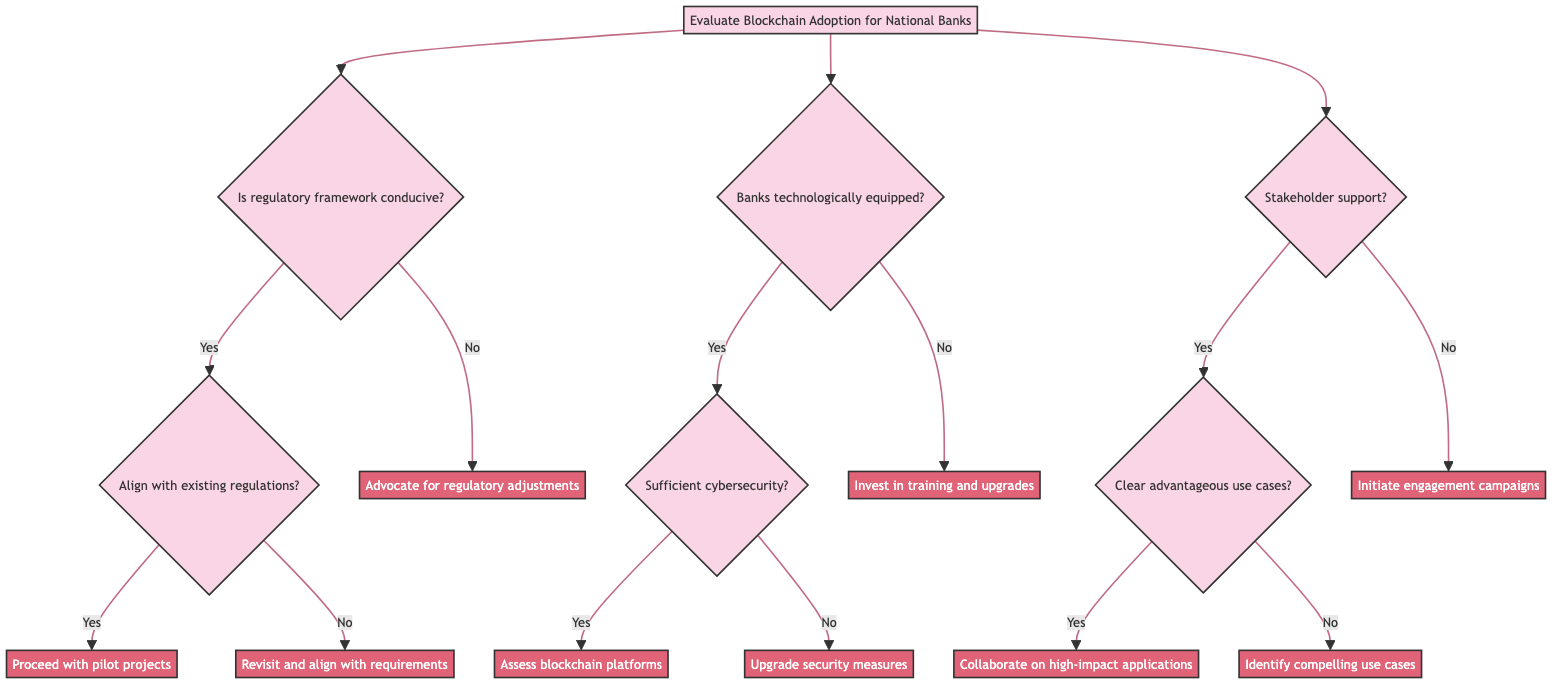What is the first question in the decision tree? The first question presented in the decision tree relates to the regulatory aspect: "Is the regulatory framework conducive to blockchain implementation?" It is the initial point of consideration for evaluating blockchain adoption.
Answer: Is the regulatory framework conducive to blockchain implementation? How many main criteria are evaluated in this decision tree? The decision tree evaluates three main criteria: the regulatory framework, technological readiness of banks, and stakeholder support. Counting these gives a total of three criteria to assess blockchain adoption.
Answer: 3 What is the outcome if the regulatory framework is not conducive? If the regulatory framework is deemed not conducive, the outcome is to "Advocate for regulatory adjustments. Engage in dialogue with lawmakers." This reflects the action to take based on this evaluation.
Answer: Advocate for regulatory adjustments. Engage in dialogue with lawmakers What should be done if banks are not technologically equipped? If it's determined that the banks are not technologically equipped for blockchain integration, the recommended action is to "Invest in staff training and technology upgrades." This indicates the necessary measures to improve technological preparedness.
Answer: Invest in staff training and technology upgrades What happens if there is sufficient cybersecurity infrastructure? When there is sufficient cybersecurity infrastructure, the next step involves assessing the blockchain platforms for security and performance. This outlines the follow-up action after confirming cybersecurity readiness.
Answer: Assess blockchain platforms for security and performance What should be done if there is no stakeholder support? In cases where there is no stakeholder support from major financial institutions, the action to take is to "Initiate stakeholder engagement and education campaigns." This shows a proactive approach to garner support and understanding of blockchain.
Answer: Initiate stakeholder engagement and education campaigns If major financial institutions support the adoption, what is the next question to ask? If there is stakeholder support from major financial institutions, the next question to evaluate is whether there are "clear use cases that offer significant advantages." This indicates a deeper evaluation of practicality after securing support.
Answer: Are there clear use cases that offer significant advantages? What is the recommended action if there are clear advantageous use cases? Should there be clear advantageous use cases, the recommendation would be to "Collaborate with pilot banks. Focus on high-impact applications like transaction settlement." This specifies collaboration for implementation practices based on identified use cases.
Answer: Collaborate with pilot banks. Focus on high-impact applications like transaction settlement 